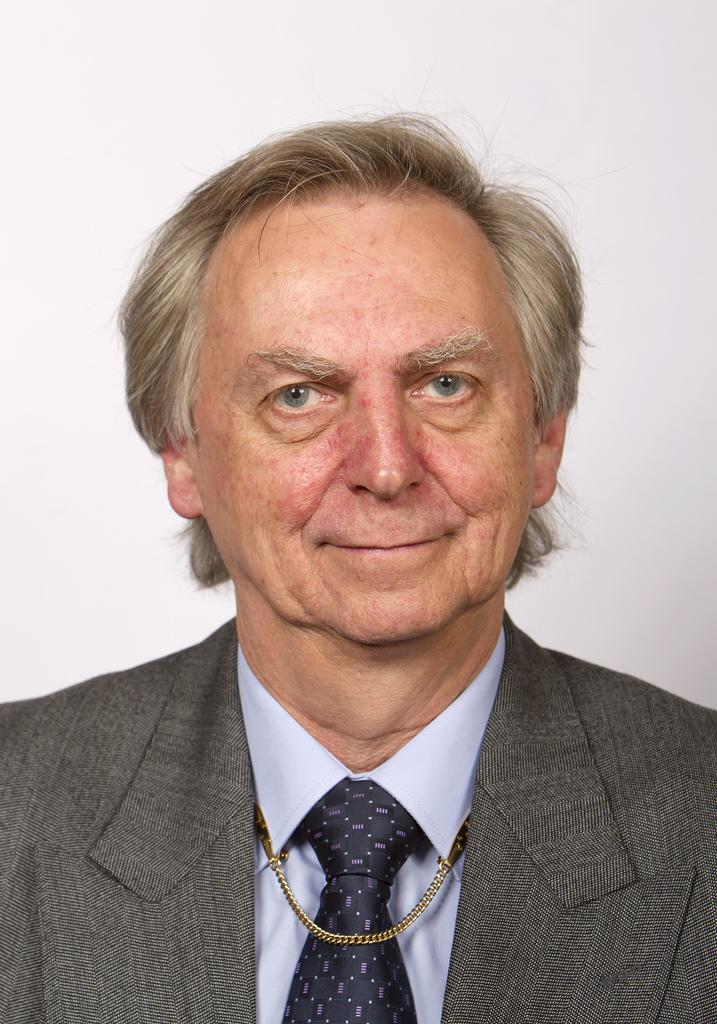Who is the main subject in the image? There is a man in the center of the image. What is the man wearing? The man is wearing a suit. What can be seen in the background of the image? There is a wall in the background of the image. Can you see a wren perched on the man's shoulder in the image? No, there is no wren present in the image. 